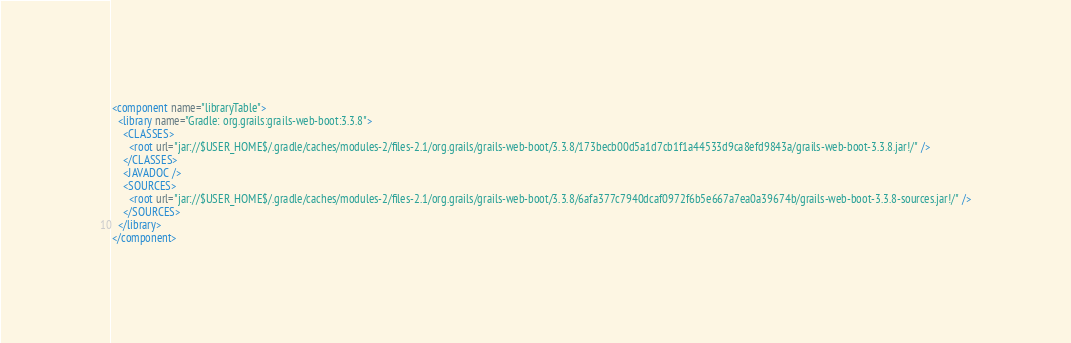Convert code to text. <code><loc_0><loc_0><loc_500><loc_500><_XML_><component name="libraryTable">
  <library name="Gradle: org.grails:grails-web-boot:3.3.8">
    <CLASSES>
      <root url="jar://$USER_HOME$/.gradle/caches/modules-2/files-2.1/org.grails/grails-web-boot/3.3.8/173becb00d5a1d7cb1f1a44533d9ca8efd9843a/grails-web-boot-3.3.8.jar!/" />
    </CLASSES>
    <JAVADOC />
    <SOURCES>
      <root url="jar://$USER_HOME$/.gradle/caches/modules-2/files-2.1/org.grails/grails-web-boot/3.3.8/6afa377c7940dcaf0972f6b5e667a7ea0a39674b/grails-web-boot-3.3.8-sources.jar!/" />
    </SOURCES>
  </library>
</component></code> 